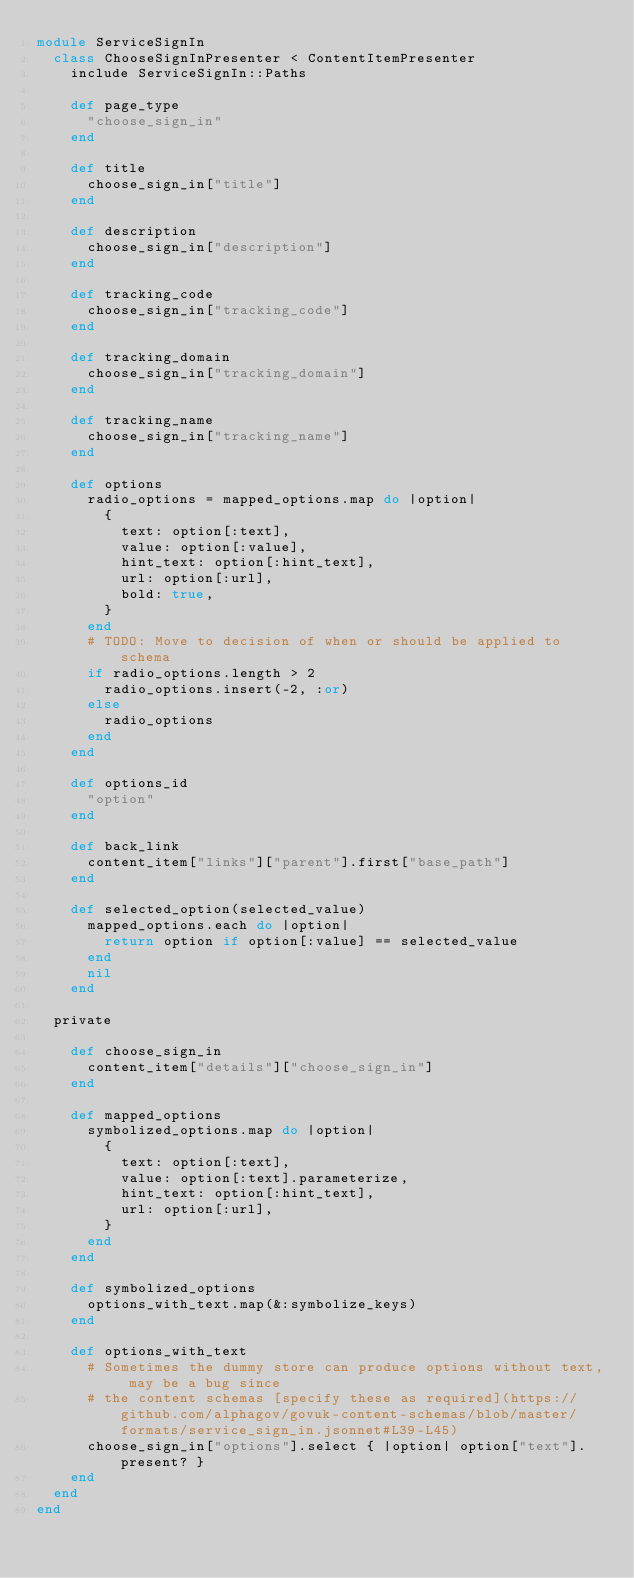Convert code to text. <code><loc_0><loc_0><loc_500><loc_500><_Ruby_>module ServiceSignIn
  class ChooseSignInPresenter < ContentItemPresenter
    include ServiceSignIn::Paths

    def page_type
      "choose_sign_in"
    end

    def title
      choose_sign_in["title"]
    end

    def description
      choose_sign_in["description"]
    end

    def tracking_code
      choose_sign_in["tracking_code"]
    end

    def tracking_domain
      choose_sign_in["tracking_domain"]
    end

    def tracking_name
      choose_sign_in["tracking_name"]
    end

    def options
      radio_options = mapped_options.map do |option|
        {
          text: option[:text],
          value: option[:value],
          hint_text: option[:hint_text],
          url: option[:url],
          bold: true,
        }
      end
      # TODO: Move to decision of when or should be applied to schema
      if radio_options.length > 2
        radio_options.insert(-2, :or)
      else
        radio_options
      end
    end

    def options_id
      "option"
    end

    def back_link
      content_item["links"]["parent"].first["base_path"]
    end

    def selected_option(selected_value)
      mapped_options.each do |option|
        return option if option[:value] == selected_value
      end
      nil
    end

  private

    def choose_sign_in
      content_item["details"]["choose_sign_in"]
    end

    def mapped_options
      symbolized_options.map do |option|
        {
          text: option[:text],
          value: option[:text].parameterize,
          hint_text: option[:hint_text],
          url: option[:url],
        }
      end
    end

    def symbolized_options
      options_with_text.map(&:symbolize_keys)
    end

    def options_with_text
      # Sometimes the dummy store can produce options without text, may be a bug since
      # the content schemas [specify these as required](https://github.com/alphagov/govuk-content-schemas/blob/master/formats/service_sign_in.jsonnet#L39-L45)
      choose_sign_in["options"].select { |option| option["text"].present? }
    end
  end
end
</code> 